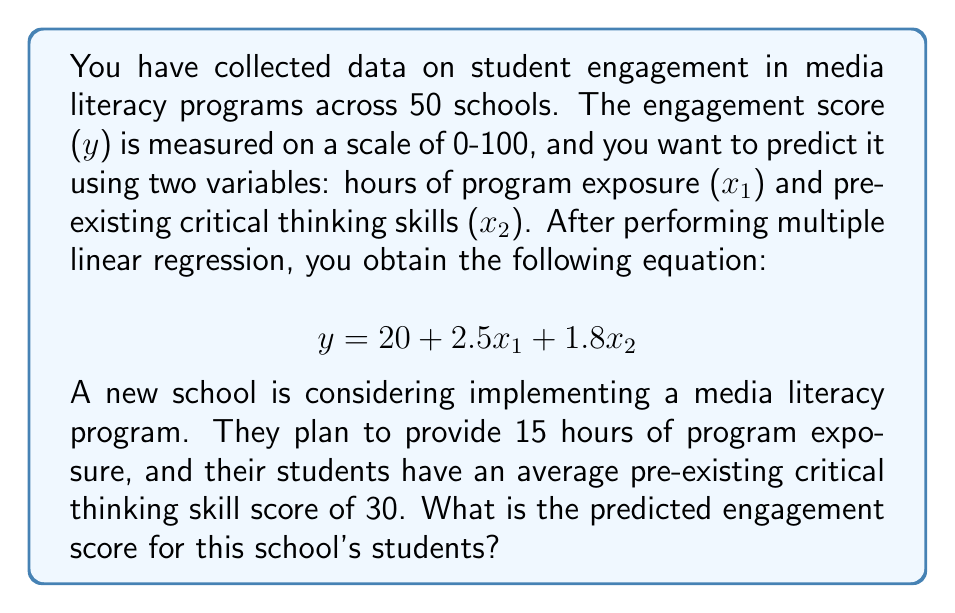Can you answer this question? To solve this problem, we'll use the given multiple linear regression equation and substitute the values for the new school:

1. The regression equation is:
   $$ y = 20 + 2.5x_1 + 1.8x_2 $$

2. We're given:
   - $x_1$ (hours of program exposure) = 15
   - $x_2$ (pre-existing critical thinking skills) = 30

3. Let's substitute these values into the equation:
   $$ y = 20 + 2.5(15) + 1.8(30) $$

4. Now, let's calculate each term:
   - $2.5(15) = 37.5$
   - $1.8(30) = 54$

5. Substituting these values:
   $$ y = 20 + 37.5 + 54 $$

6. Finally, we sum up all the terms:
   $$ y = 111.5 $$

Therefore, the predicted engagement score for the new school's students is 111.5.
Answer: 111.5 